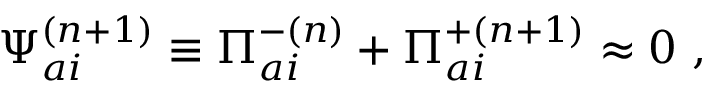Convert formula to latex. <formula><loc_0><loc_0><loc_500><loc_500>{ \Psi } _ { a i } ^ { ( n + 1 ) } \equiv \Pi _ { a i } ^ { - ( n ) } + { \Pi } _ { a i } ^ { + ( n + 1 ) } \approx 0 \ ,</formula> 